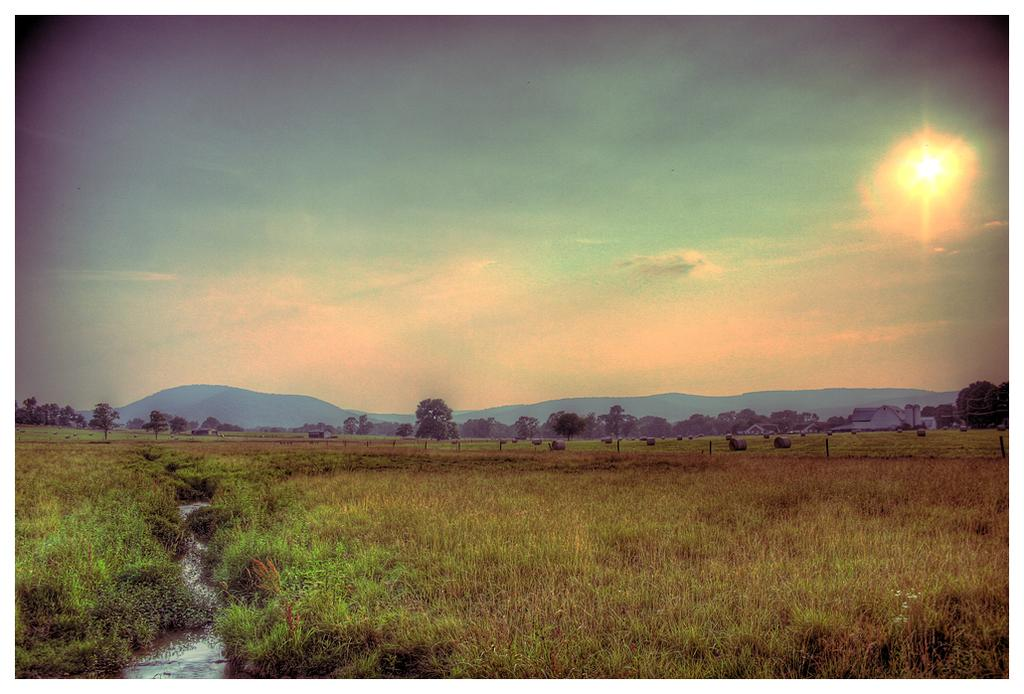What type of landscape is depicted in the image? The image features a crop, trees, and hills. Can you describe the natural elements in the image? There are trees and hills visible in the image, along with a crop. What is the condition of the sky in the image? The sun is visible in the sky in the image. What statement can be made about the care of the trees in the image? There is no information provided about the care of the trees in the image, so it cannot be determined from the image alone. 